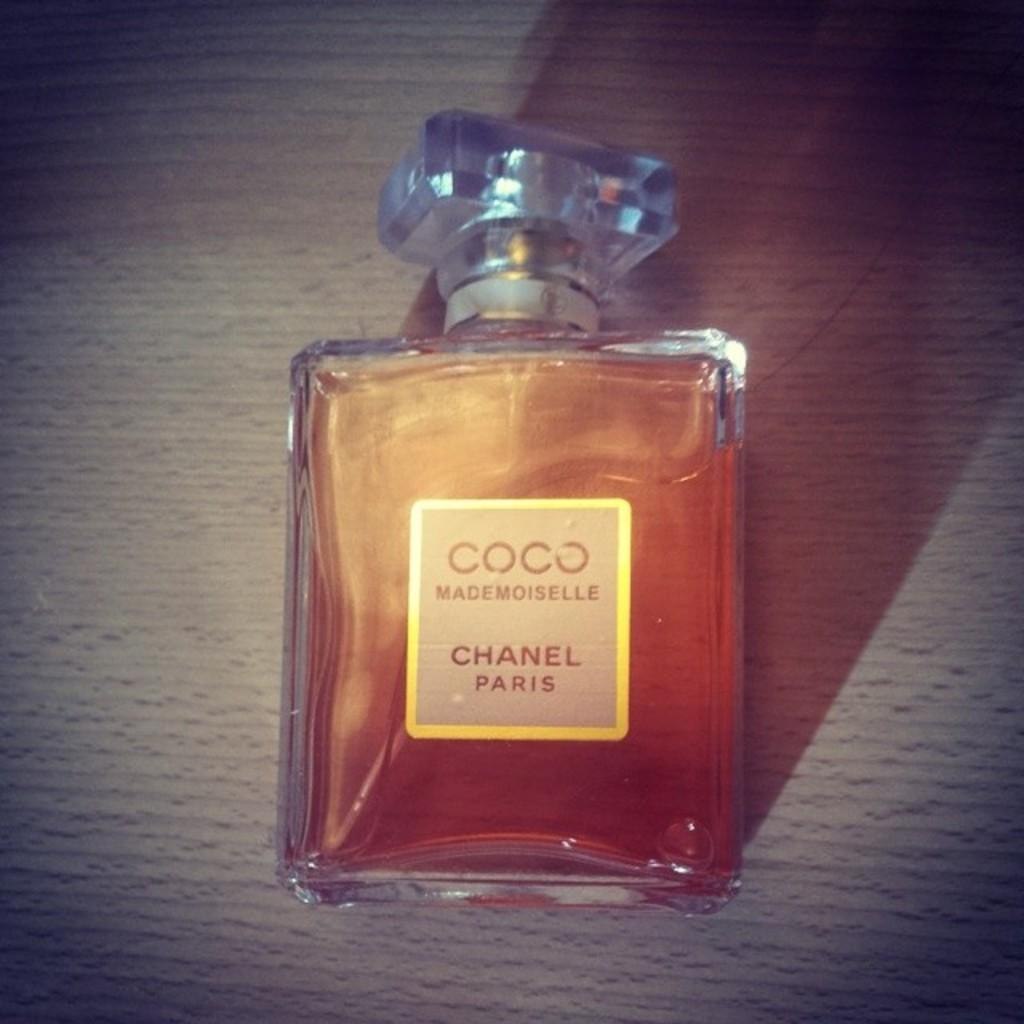Provide a one-sentence caption for the provided image. A bottle of Coco Chanel rests on a wooden surface. 